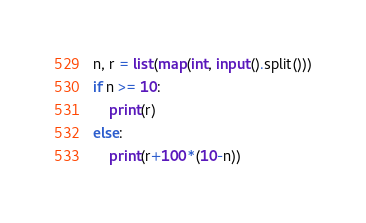Convert code to text. <code><loc_0><loc_0><loc_500><loc_500><_Python_>n, r = list(map(int, input().split()))
if n >= 10:
    print(r)
else:
    print(r+100*(10-n))
</code> 